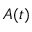Convert formula to latex. <formula><loc_0><loc_0><loc_500><loc_500>A ( t )</formula> 